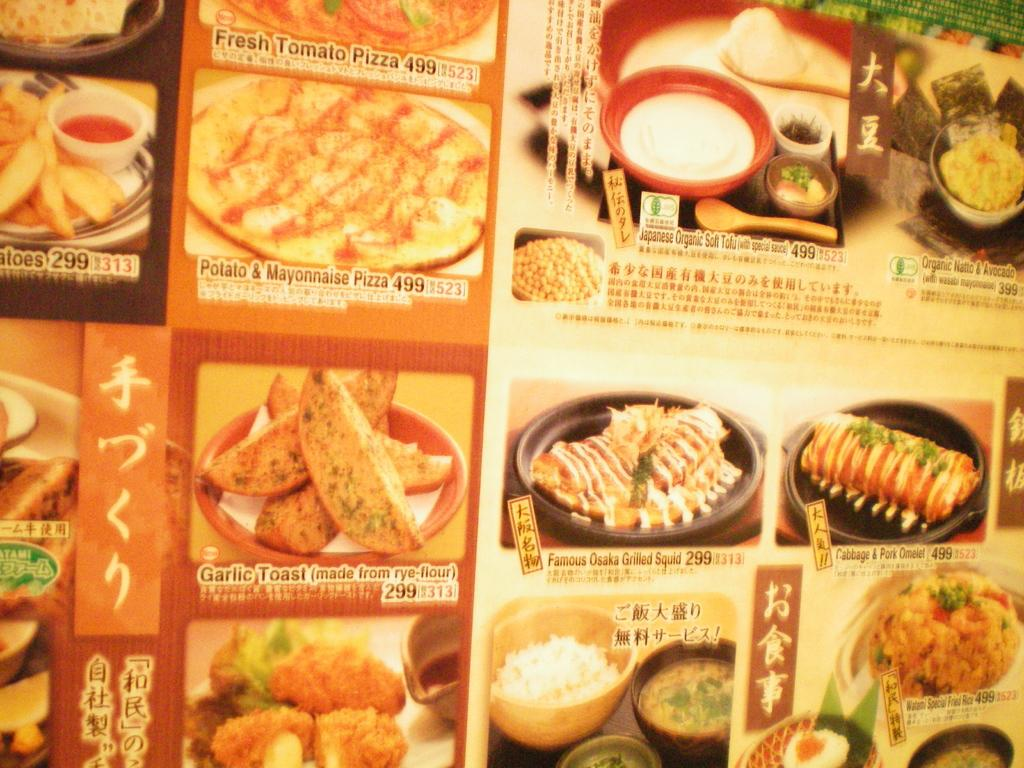What is present in the image? There is a poster in the image. What is depicted on the poster? The poster contains an image of food items. Are there any words on the poster? Yes, the poster contains text. What type of mitten is being advertised on the poster? There is no mitten present on the poster; it contains an image of food items and text. 